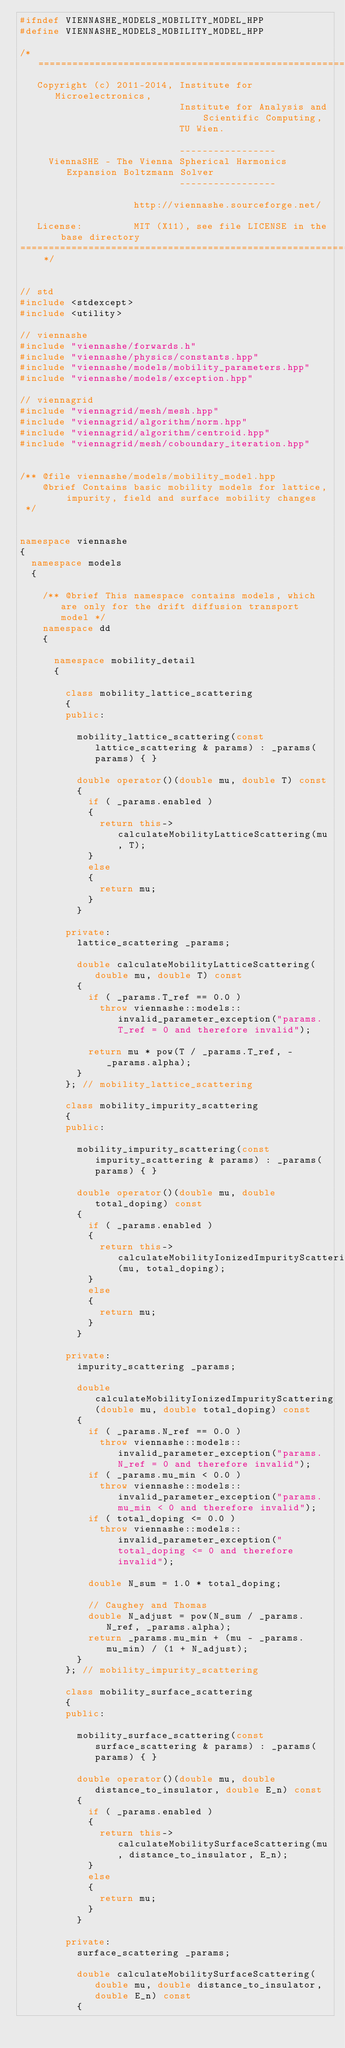<code> <loc_0><loc_0><loc_500><loc_500><_C++_>#ifndef VIENNASHE_MODELS_MOBILITY_MODEL_HPP
#define VIENNASHE_MODELS_MOBILITY_MODEL_HPP

/* ============================================================================
   Copyright (c) 2011-2014, Institute for Microelectronics,
                            Institute for Analysis and Scientific Computing,
                            TU Wien.

                            -----------------
     ViennaSHE - The Vienna Spherical Harmonics Expansion Boltzmann Solver
                            -----------------

                    http://viennashe.sourceforge.net/

   License:         MIT (X11), see file LICENSE in the base directory
=============================================================================== */


// std
#include <stdexcept>
#include <utility>

// viennashe
#include "viennashe/forwards.h"
#include "viennashe/physics/constants.hpp"
#include "viennashe/models/mobility_parameters.hpp"
#include "viennashe/models/exception.hpp"

// viennagrid
#include "viennagrid/mesh/mesh.hpp"
#include "viennagrid/algorithm/norm.hpp"
#include "viennagrid/algorithm/centroid.hpp"
#include "viennagrid/mesh/coboundary_iteration.hpp"


/** @file viennashe/models/mobility_model.hpp
    @brief Contains basic mobility models for lattice, impurity, field and surface mobility changes
 */


namespace viennashe
{
  namespace models
  {

    /** @brief This namespace contains models, which are only for the drift diffusion transport model */
    namespace dd
    {

      namespace mobility_detail
      {

        class mobility_lattice_scattering
        {
        public:

          mobility_lattice_scattering(const lattice_scattering & params) : _params(params) { }

          double operator()(double mu, double T) const
          {
            if ( _params.enabled )
            {
              return this->calculateMobilityLatticeScattering(mu, T);
            }
            else
            {
              return mu;
            }
          }

        private:
          lattice_scattering _params;

          double calculateMobilityLatticeScattering(double mu, double T) const
          {
            if ( _params.T_ref == 0.0 )
              throw viennashe::models::invalid_parameter_exception("params.T_ref = 0 and therefore invalid");

            return mu * pow(T / _params.T_ref, -_params.alpha);
          }
        }; // mobility_lattice_scattering

        class mobility_impurity_scattering
        {
        public:

          mobility_impurity_scattering(const impurity_scattering & params) : _params(params) { }

          double operator()(double mu, double total_doping) const
          {
            if ( _params.enabled )
            {
              return this->calculateMobilityIonizedImpurityScattering(mu, total_doping);
            }
            else
            {
              return mu;
            }
          }

        private:
          impurity_scattering _params;

          double calculateMobilityIonizedImpurityScattering(double mu, double total_doping) const
          {
            if ( _params.N_ref == 0.0 )
              throw viennashe::models::invalid_parameter_exception("params.N_ref = 0 and therefore invalid");
            if ( _params.mu_min < 0.0 )
              throw viennashe::models::invalid_parameter_exception("params.mu_min < 0 and therefore invalid");
            if ( total_doping <= 0.0 )
              throw viennashe::models::invalid_parameter_exception("total_doping <= 0 and therefore invalid");

            double N_sum = 1.0 * total_doping;

            // Caughey and Thomas
            double N_adjust = pow(N_sum / _params.N_ref, _params.alpha);
            return _params.mu_min + (mu - _params.mu_min) / (1 + N_adjust);
          }
        }; // mobility_impurity_scattering

        class mobility_surface_scattering
        {
        public:

          mobility_surface_scattering(const surface_scattering & params) : _params(params) { }

          double operator()(double mu, double distance_to_insulator, double E_n) const
          {
            if ( _params.enabled )
            {
              return this->calculateMobilitySurfaceScattering(mu, distance_to_insulator, E_n);
            }
            else
            {
              return mu;
            }
          }

        private:
          surface_scattering _params;

          double calculateMobilitySurfaceScattering(double mu, double distance_to_insulator, double E_n) const
          {</code> 